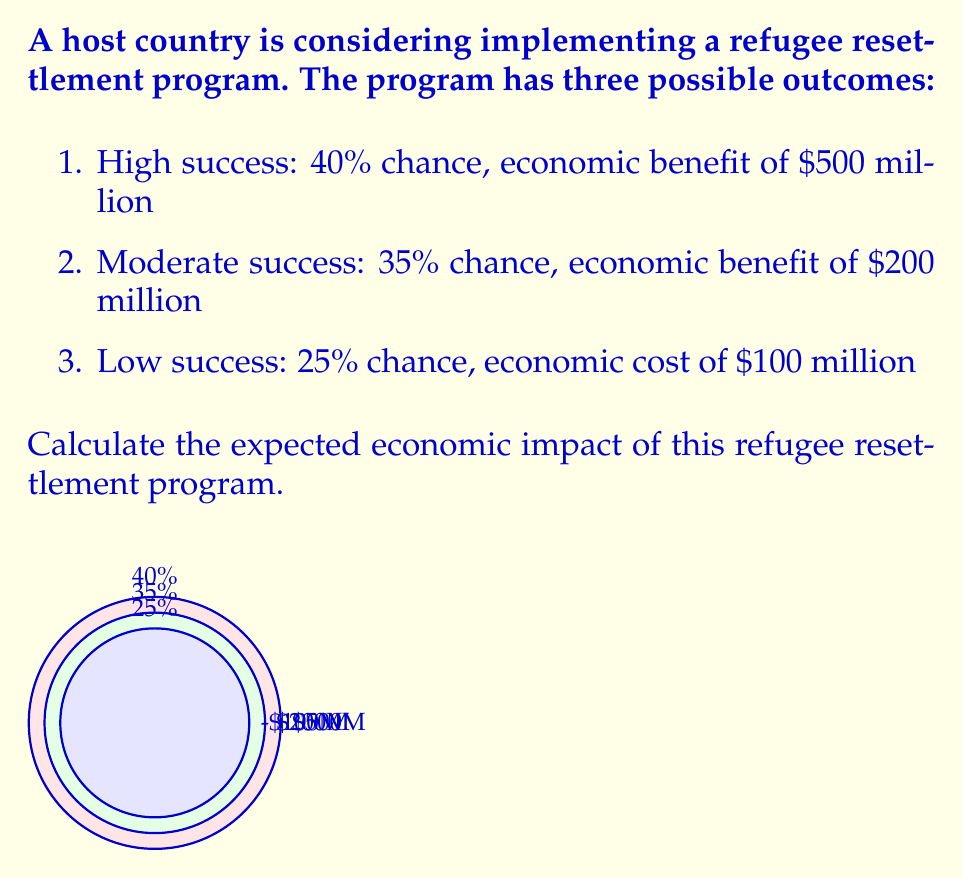Help me with this question. To calculate the expected economic impact, we need to use the concept of expected value. The expected value is the sum of each possible outcome multiplied by its probability.

Let's break it down step by step:

1) For the high success scenario:
   Probability = 40% = 0.40
   Economic benefit = $500 million
   Expected value = $500 million × 0.40 = $200 million

2) For the moderate success scenario:
   Probability = 35% = 0.35
   Economic benefit = $200 million
   Expected value = $200 million × 0.35 = $70 million

3) For the low success scenario:
   Probability = 25% = 0.25
   Economic cost = $100 million (note this is a cost, so it's negative)
   Expected value = -$100 million × 0.25 = -$25 million

4) Now, we sum these expected values:

   $$E = (500 \times 0.40) + (200 \times 0.35) + (-100 \times 0.25)$$
   $$E = 200 + 70 - 25 = 245$$

Therefore, the expected economic impact is $245 million.
Answer: $245 million 